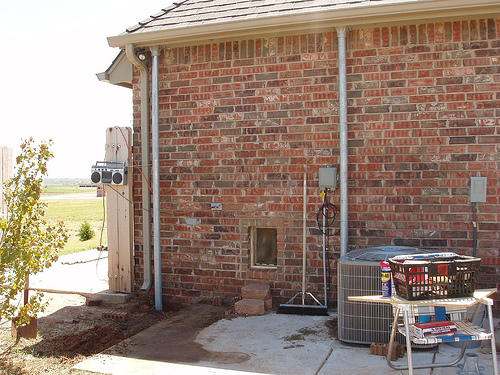<image>
Is the gutters next to the roof? Yes. The gutters is positioned adjacent to the roof, located nearby in the same general area. 